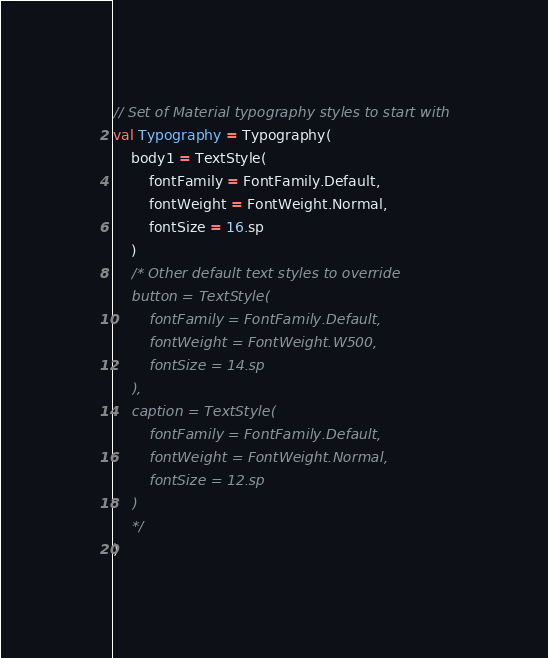<code> <loc_0><loc_0><loc_500><loc_500><_Kotlin_>
// Set of Material typography styles to start with
val Typography = Typography(
    body1 = TextStyle(
        fontFamily = FontFamily.Default,
        fontWeight = FontWeight.Normal,
        fontSize = 16.sp
    )
    /* Other default text styles to override
    button = TextStyle(
        fontFamily = FontFamily.Default,
        fontWeight = FontWeight.W500,
        fontSize = 14.sp
    ),
    caption = TextStyle(
        fontFamily = FontFamily.Default,
        fontWeight = FontWeight.Normal,
        fontSize = 12.sp
    )
    */
)</code> 